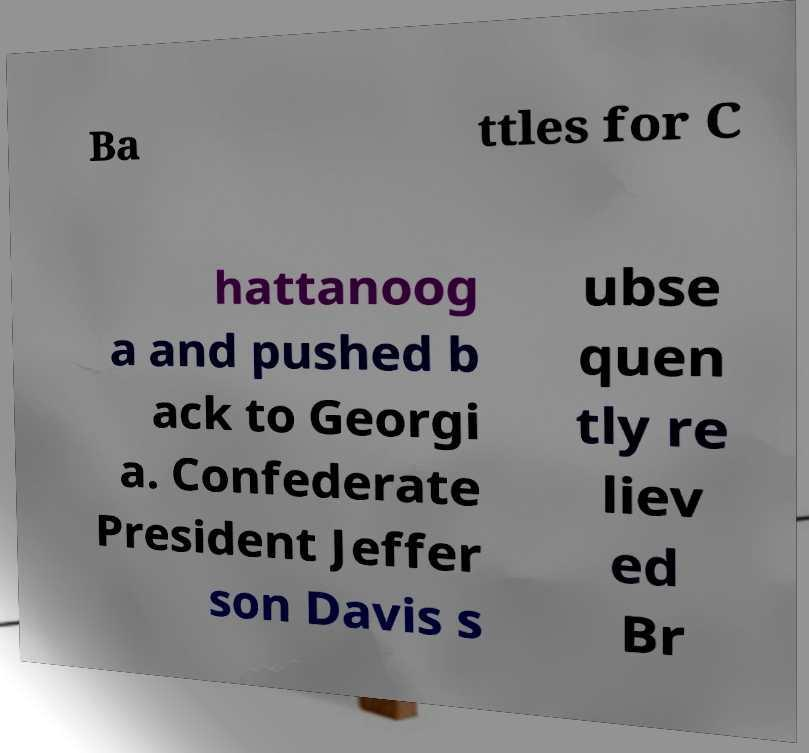Can you read and provide the text displayed in the image?This photo seems to have some interesting text. Can you extract and type it out for me? Ba ttles for C hattanoog a and pushed b ack to Georgi a. Confederate President Jeffer son Davis s ubse quen tly re liev ed Br 